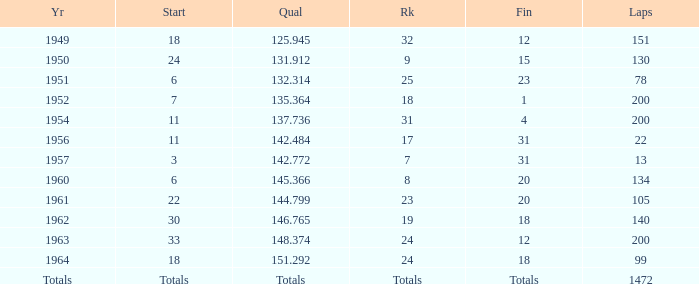Specify the ending with greater than 200 laps. Totals. 